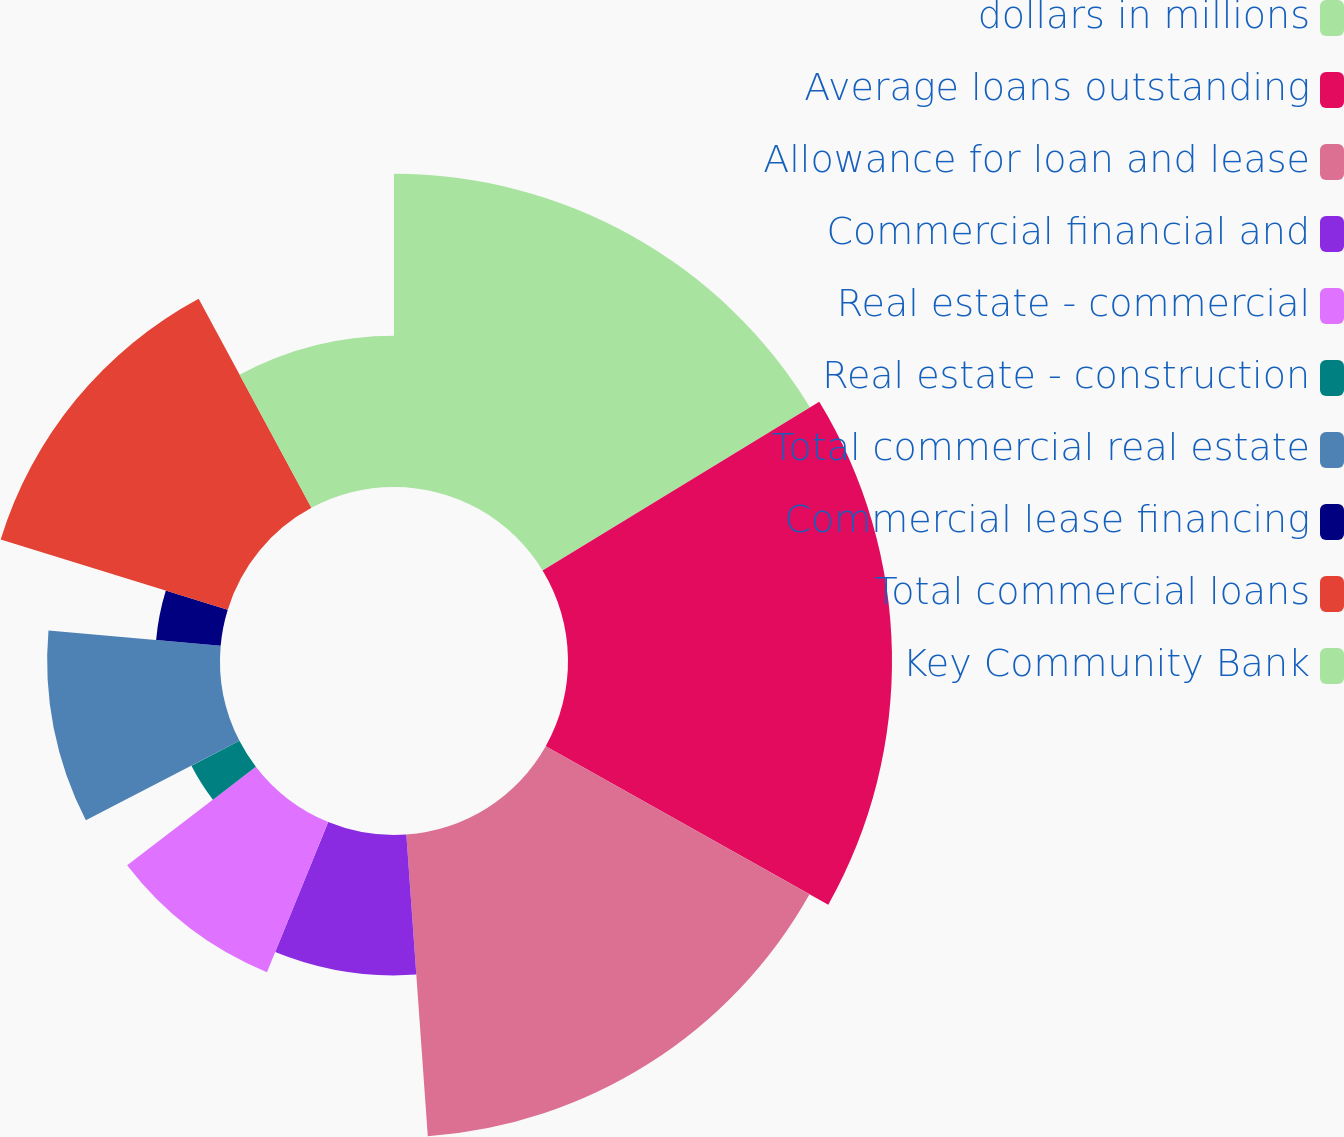Convert chart. <chart><loc_0><loc_0><loc_500><loc_500><pie_chart><fcel>dollars in millions<fcel>Average loans outstanding<fcel>Allowance for loan and lease<fcel>Commercial financial and<fcel>Real estate - commercial<fcel>Real estate - construction<fcel>Total commercial real estate<fcel>Commercial lease financing<fcel>Total commercial loans<fcel>Key Community Bank<nl><fcel>16.29%<fcel>16.85%<fcel>15.73%<fcel>7.3%<fcel>8.43%<fcel>2.81%<fcel>8.99%<fcel>3.37%<fcel>12.36%<fcel>7.87%<nl></chart> 